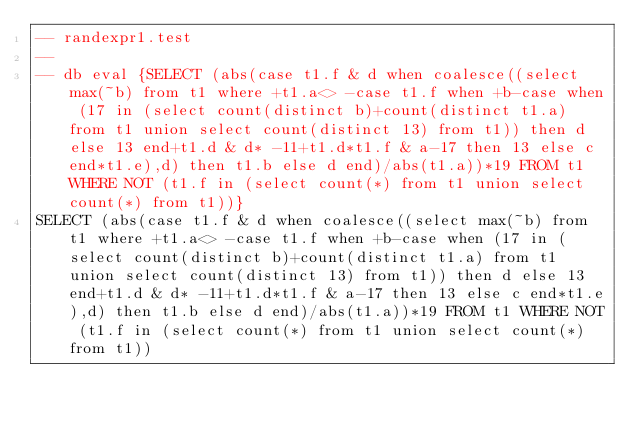<code> <loc_0><loc_0><loc_500><loc_500><_SQL_>-- randexpr1.test
-- 
-- db eval {SELECT (abs(case t1.f & d when coalesce((select max(~b) from t1 where +t1.a<> -case t1.f when +b-case when (17 in (select count(distinct b)+count(distinct t1.a) from t1 union select count(distinct 13) from t1)) then d else 13 end+t1.d & d* -11+t1.d*t1.f & a-17 then 13 else c end*t1.e),d) then t1.b else d end)/abs(t1.a))*19 FROM t1 WHERE NOT (t1.f in (select count(*) from t1 union select count(*) from t1))}
SELECT (abs(case t1.f & d when coalesce((select max(~b) from t1 where +t1.a<> -case t1.f when +b-case when (17 in (select count(distinct b)+count(distinct t1.a) from t1 union select count(distinct 13) from t1)) then d else 13 end+t1.d & d* -11+t1.d*t1.f & a-17 then 13 else c end*t1.e),d) then t1.b else d end)/abs(t1.a))*19 FROM t1 WHERE NOT (t1.f in (select count(*) from t1 union select count(*) from t1))</code> 